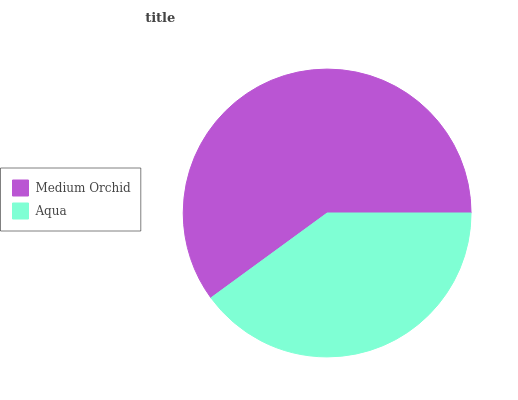Is Aqua the minimum?
Answer yes or no. Yes. Is Medium Orchid the maximum?
Answer yes or no. Yes. Is Aqua the maximum?
Answer yes or no. No. Is Medium Orchid greater than Aqua?
Answer yes or no. Yes. Is Aqua less than Medium Orchid?
Answer yes or no. Yes. Is Aqua greater than Medium Orchid?
Answer yes or no. No. Is Medium Orchid less than Aqua?
Answer yes or no. No. Is Medium Orchid the high median?
Answer yes or no. Yes. Is Aqua the low median?
Answer yes or no. Yes. Is Aqua the high median?
Answer yes or no. No. Is Medium Orchid the low median?
Answer yes or no. No. 